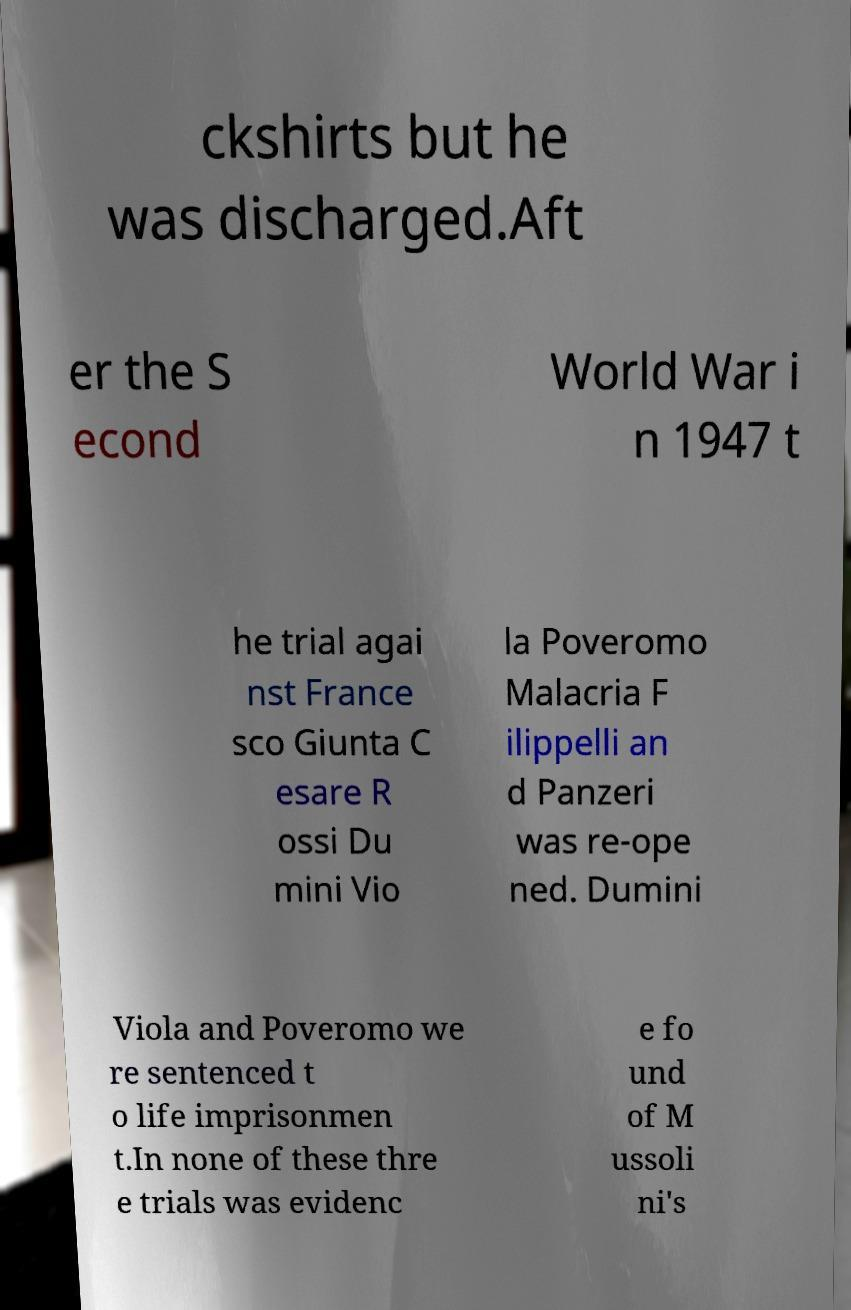I need the written content from this picture converted into text. Can you do that? ckshirts but he was discharged.Aft er the S econd World War i n 1947 t he trial agai nst France sco Giunta C esare R ossi Du mini Vio la Poveromo Malacria F ilippelli an d Panzeri was re-ope ned. Dumini Viola and Poveromo we re sentenced t o life imprisonmen t.In none of these thre e trials was evidenc e fo und of M ussoli ni's 